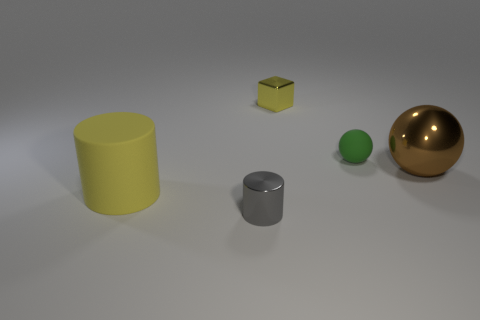Subtract all brown balls. How many balls are left? 1 Subtract 1 cylinders. How many cylinders are left? 1 Subtract all cubes. How many objects are left? 4 Subtract all red balls. Subtract all brown cylinders. How many balls are left? 2 Subtract all red cubes. How many cyan balls are left? 0 Add 2 large brown metallic cylinders. How many objects exist? 7 Subtract all big brown metallic balls. Subtract all brown shiny balls. How many objects are left? 3 Add 4 large shiny balls. How many large shiny balls are left? 5 Add 1 green metal things. How many green metal things exist? 1 Subtract 0 purple cylinders. How many objects are left? 5 